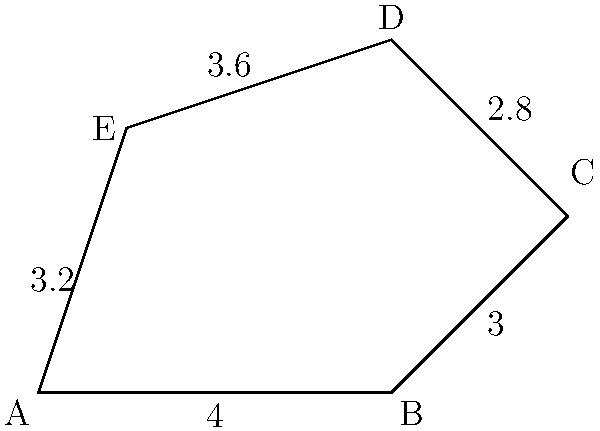The irregular polygon ABCDE represents the workflow stages of an AI-powered legal research process. Given that the lengths of the sides are AB = 4 units, BC = 3 units, CD = 2.8 units, DE = 3.6 units, and EA = 3.2 units, calculate the perimeter of the polygon. Round your answer to one decimal place. To calculate the perimeter of the irregular polygon, we need to sum up the lengths of all its sides. Let's break it down step-by-step:

1. Identify the given side lengths:
   - AB = 4 units
   - BC = 3 units
   - CD = 2.8 units
   - DE = 3.6 units
   - EA = 3.2 units

2. Add up all the side lengths:
   $$ \text{Perimeter} = AB + BC + CD + DE + EA $$
   $$ \text{Perimeter} = 4 + 3 + 2.8 + 3.6 + 3.2 $$

3. Perform the addition:
   $$ \text{Perimeter} = 16.6 \text{ units} $$

4. Round the result to one decimal place:
   $$ \text{Perimeter} \approx 16.6 \text{ units} $$

Therefore, the perimeter of the irregular polygon representing the AI-powered legal research workflow is approximately 16.6 units.
Answer: 16.6 units 